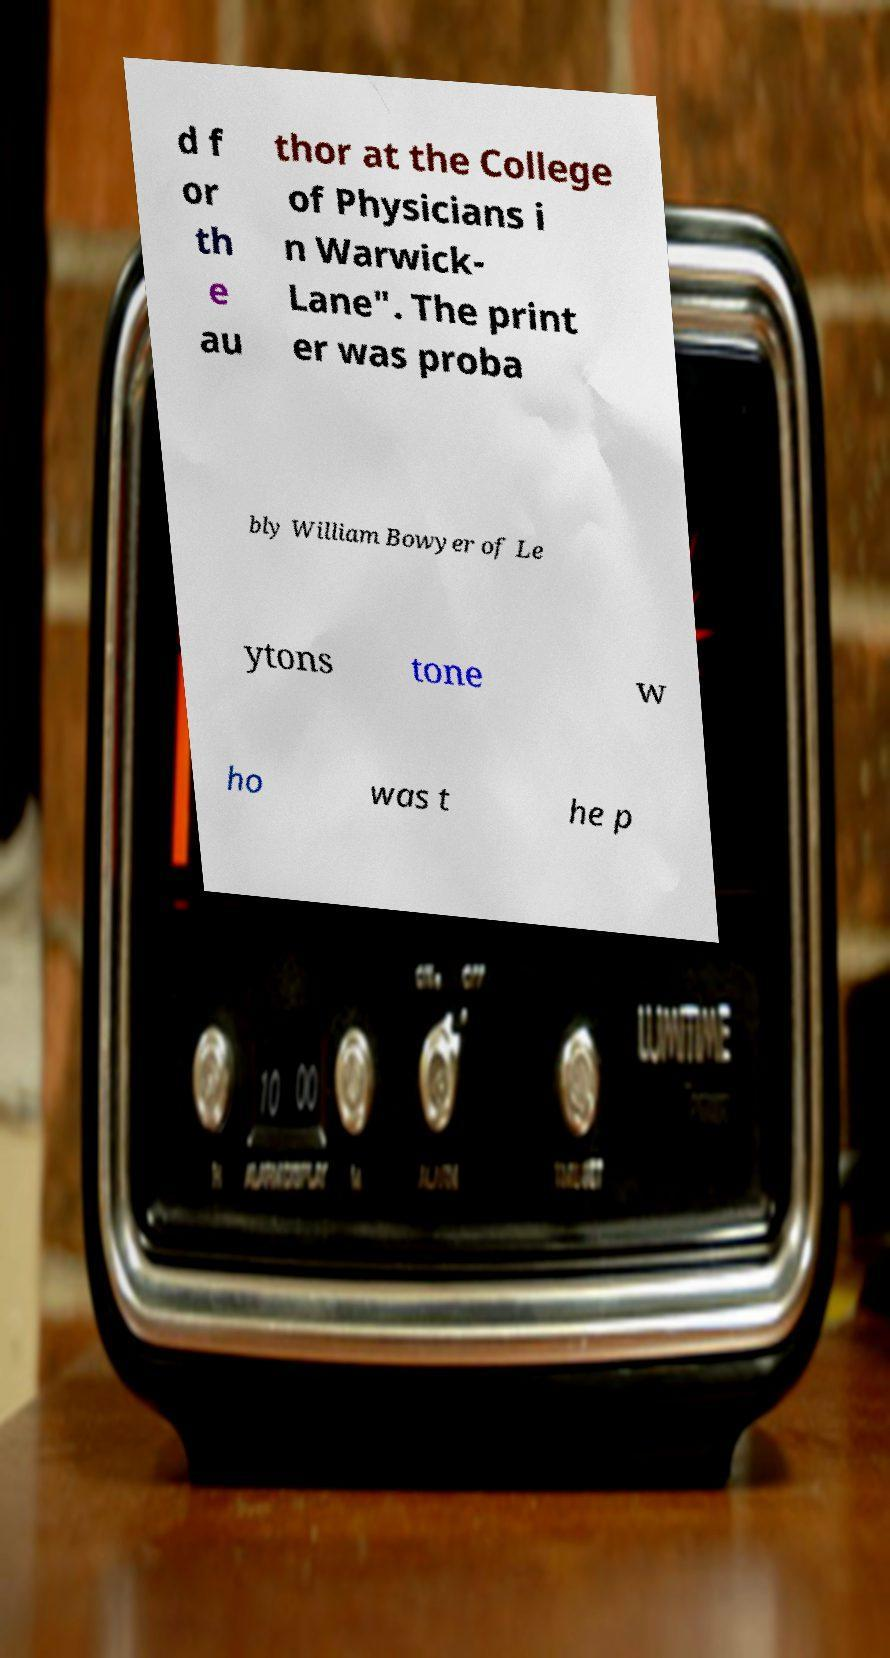Can you read and provide the text displayed in the image?This photo seems to have some interesting text. Can you extract and type it out for me? d f or th e au thor at the College of Physicians i n Warwick- Lane". The print er was proba bly William Bowyer of Le ytons tone w ho was t he p 